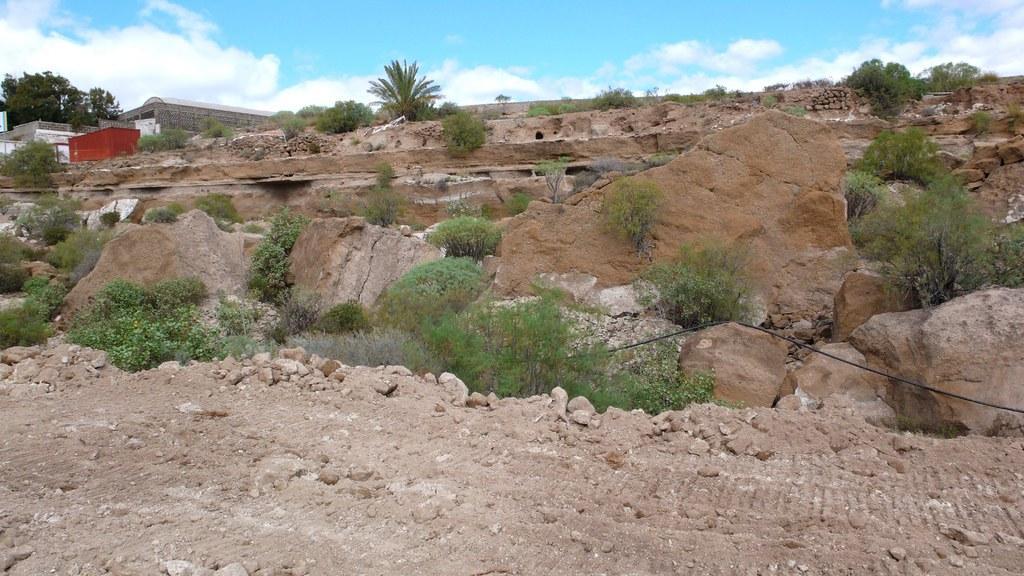Describe this image in one or two sentences. In this image, in the middle there are stones, plants, grass, trees, houses, land, sky and clouds. 